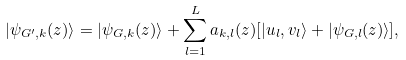<formula> <loc_0><loc_0><loc_500><loc_500>| \psi _ { G ^ { \prime } , k } ( z ) \rangle = | \psi _ { G , k } ( z ) \rangle + \sum ^ { L } _ { l = 1 } a _ { k , l } ( z ) [ | u _ { l } , v _ { l } \rangle + | \psi _ { G , l } ( z ) \rangle ] ,</formula> 